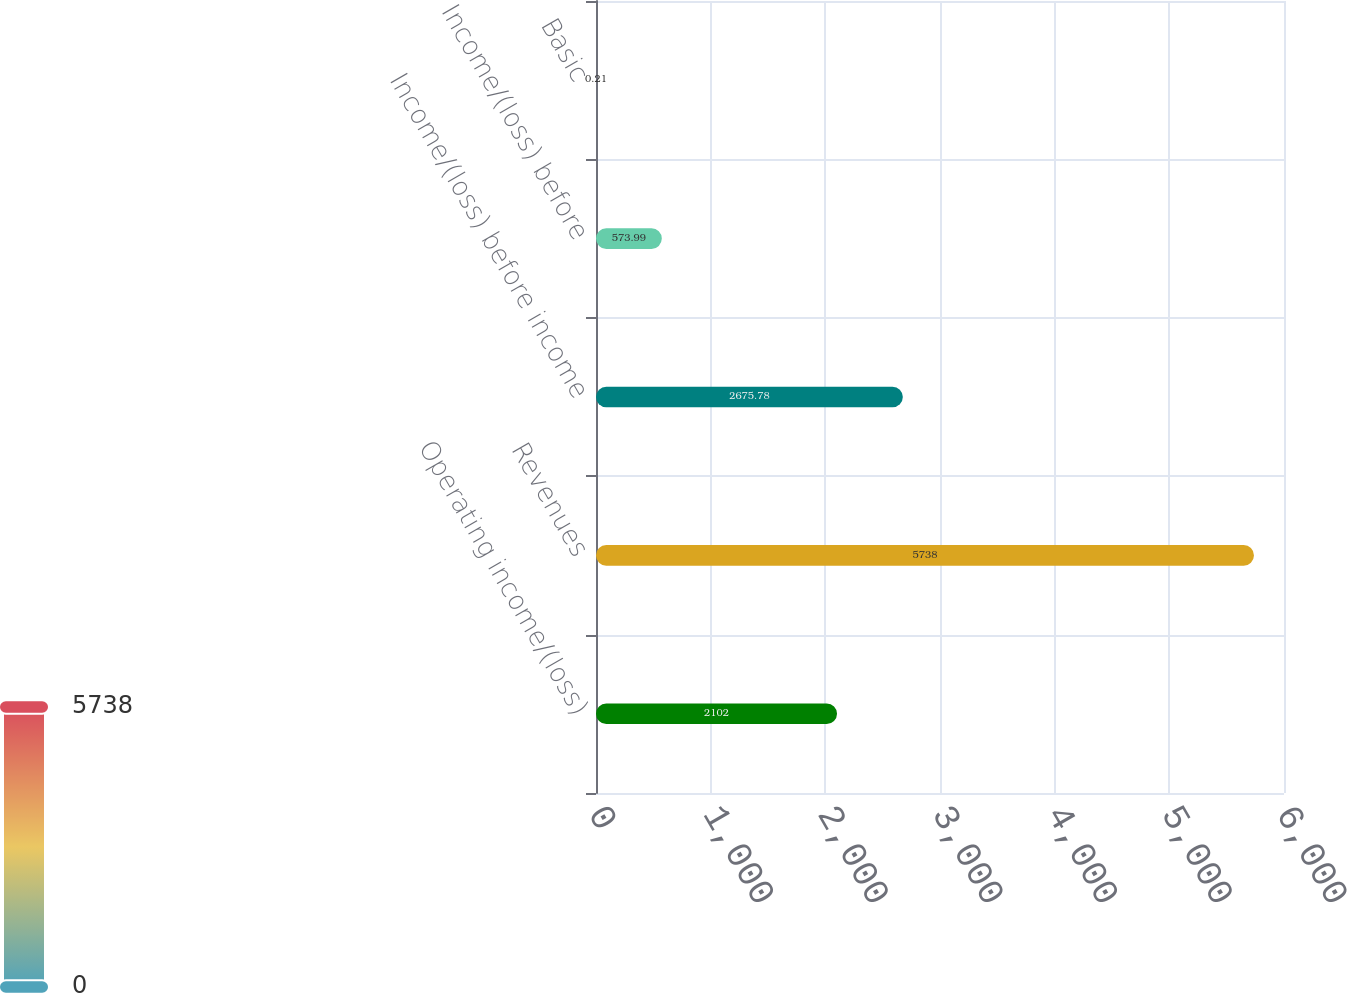<chart> <loc_0><loc_0><loc_500><loc_500><bar_chart><fcel>Operating income/(loss)<fcel>Revenues<fcel>Income/(loss) before income<fcel>Income/(loss) before<fcel>Basic<nl><fcel>2102<fcel>5738<fcel>2675.78<fcel>573.99<fcel>0.21<nl></chart> 